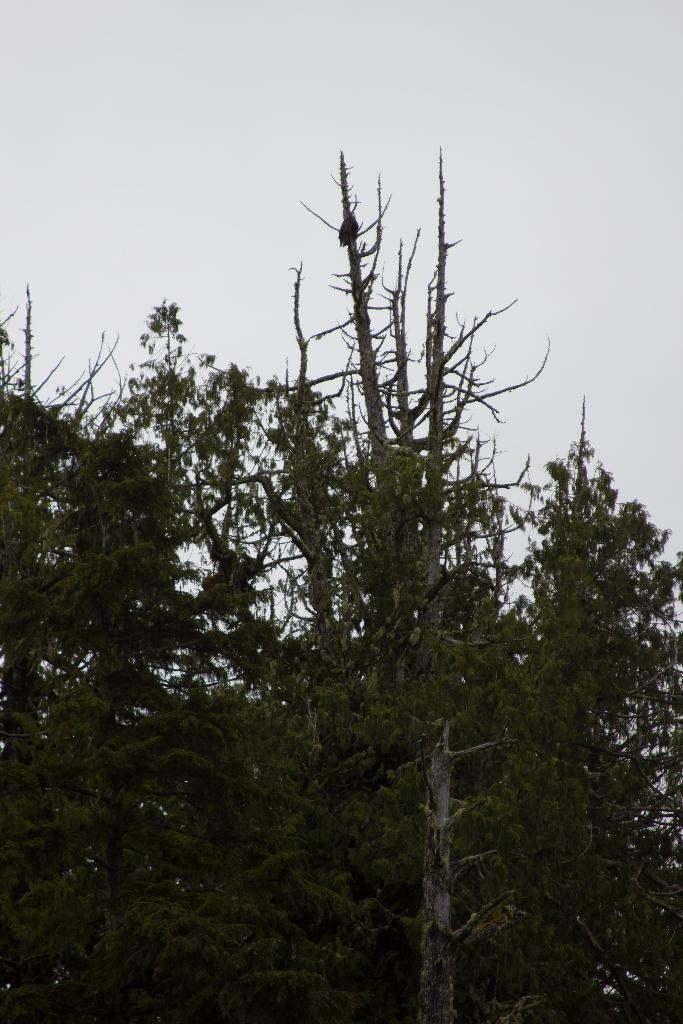What type of vegetation can be seen in the image? There are trees in the image. What is visible in the background of the image? The sky is visible in the background of the image. How many hands are visible in the image? There are no hands visible in the image; it only features trees and the sky. What type of army is present in the image? There is no army present in the image; it only features trees and the sky. 